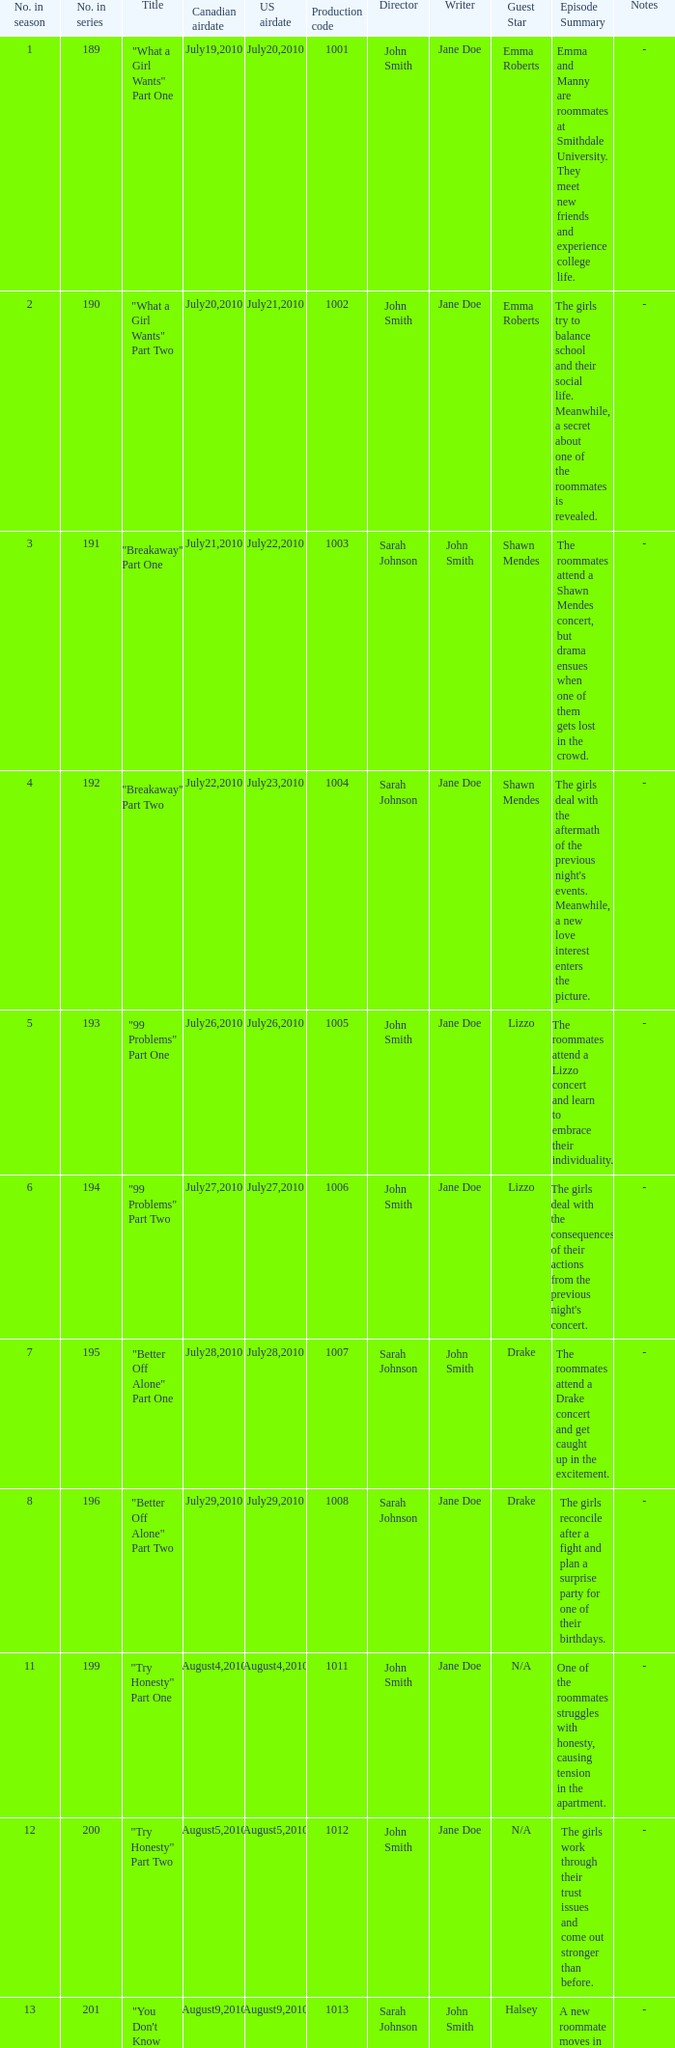Parse the full table. {'header': ['No. in season', 'No. in series', 'Title', 'Canadian airdate', 'US airdate', 'Production code', 'Director', 'Writer', 'Guest Star', 'Episode Summary', 'Notes'], 'rows': [['1', '189', '"What a Girl Wants" Part One', 'July19,2010', 'July20,2010', '1001', 'John Smith', 'Jane Doe', 'Emma Roberts', 'Emma and Manny are roommates at Smithdale University. They meet new friends and experience college life.', '-'], ['2', '190', '"What a Girl Wants" Part Two', 'July20,2010', 'July21,2010', '1002', 'John Smith', 'Jane Doe', 'Emma Roberts', 'The girls try to balance school and their social life. Meanwhile, a secret about one of the roommates is revealed.', '-'], ['3', '191', '"Breakaway" Part One', 'July21,2010', 'July22,2010', '1003', 'Sarah Johnson', 'John Smith', 'Shawn Mendes', 'The roommates attend a Shawn Mendes concert, but drama ensues when one of them gets lost in the crowd.', '-'], ['4', '192', '"Breakaway" Part Two', 'July22,2010', 'July23,2010', '1004', 'Sarah Johnson', 'Jane Doe', 'Shawn Mendes', "The girls deal with the aftermath of the previous night's events. Meanwhile, a new love interest enters the picture.", '-'], ['5', '193', '"99 Problems" Part One', 'July26,2010', 'July26,2010', '1005', 'John Smith', 'Jane Doe', 'Lizzo', 'The roommates attend a Lizzo concert and learn to embrace their individuality.', '-'], ['6', '194', '"99 Problems" Part Two', 'July27,2010', 'July27,2010', '1006', 'John Smith', 'Jane Doe', 'Lizzo', "The girls deal with the consequences of their actions from the previous night's concert.", '-'], ['7', '195', '"Better Off Alone" Part One', 'July28,2010', 'July28,2010', '1007', 'Sarah Johnson', 'John Smith', 'Drake', 'The roommates attend a Drake concert and get caught up in the excitement.', '-'], ['8', '196', '"Better Off Alone" Part Two', 'July29,2010', 'July29,2010', '1008', 'Sarah Johnson', 'Jane Doe', 'Drake', 'The girls reconcile after a fight and plan a surprise party for one of their birthdays.', '-'], ['11', '199', '"Try Honesty" Part One', 'August4,2010', 'August4,2010', '1011', 'John Smith', 'Jane Doe', 'N/A', 'One of the roommates struggles with honesty, causing tension in the apartment.', '-'], ['12', '200', '"Try Honesty" Part Two', 'August5,2010', 'August5,2010', '1012', 'John Smith', 'Jane Doe', 'N/A', 'The girls work through their trust issues and come out stronger than before.', '-'], ['13', '201', '"You Don\'t Know My Name" Part One', 'August9,2010', 'August9,2010', '1013', 'Sarah Johnson', 'John Smith', 'Halsey', 'A new roommate moves in and shakes things up.', '-'], ['14', '202', '"You Don\'t Know My Name" Part Two', 'August10,2010', 'August10,2010', '1014', 'Sarah Johnson', 'Jane Doe', 'Halsey', 'The girls learn more about their new roommate and bond over shared interests.', '-'], ['15', '203', '" My Body Is a Cage " Part One', 'August11,2010', 'August11,2010', '1015', 'John Smith', 'Jane Doe', 'Lady Gaga', 'One of the roommates opens up about a personal struggle.', '-'], ['16', '204', '" My Body Is a Cage " Part Two', 'August12,2010', 'August12,2010', '1016', 'John Smith', 'Jane Doe', 'Lady Gaga', 'The girls support their friend and come up with a plan to help her.', '-'], ['17', '205', '"Tears Dry on Their Own" Part One', 'August16,2010', 'August16,2010', '1017', 'Sarah Johnson', 'John Smith', 'N/A', 'The roommates deal with the aftermath of a breakup.', '-'], ['18', '206', '"Tears Dry on Their Own" Part Two', 'August17,2010', 'August17,2010', '1018', 'Sarah Johnson', 'Jane Doe', 'N/A', 'The girls help their friend move on and realize the importance of self-love.', '-'], ['19', '207', '"Still Fighting It" Part One', 'August18,2010', 'August18,2010', '1019', 'John Smith', 'Jane Doe', 'Ariana Grande', 'The roommates attend an Ariana Grande concert and deal with conflicting emotions.', '-'], ['20', '208', '"Still Fighting It" Part Two', 'August19,2010', 'August19,2010', '1020', 'John Smith', 'Jane Doe', 'Ariana Grande', 'The girls reflect on their personal journeys and how far they have come.', '-'], ['21', '209', '"Purple Pills" Part One', 'August23,2010', 'August23,2010', '1021', 'Sarah Johnson', 'John Smith', 'N/A', 'The roommates experiment with drugs and face the consequences of their actions.', '-'], ['22', '210', '"Purple Pills" Part Two', 'August24,2010', 'August24,2010', '1022', 'Sarah Johnson', 'Jane Doe', 'N/A', 'The girls deal with the fallout of their drug use and try to move forward.', '-'], ['23', '211', '"All Falls Down" Part One', 'August25,2010', 'August25,2010', '1023', 'John Smith', 'Jane Doe', 'Post Malone', 'The roommates attend a Post Malone concert and confront their insecurities.', '-'], ['24', '212', '"All Falls Down" Part Two', 'August26,2010', 'August26,2010', '1024', 'John Smith', 'Jane Doe', 'Post Malone', 'The girls support each other through personal struggles and make plans for the future.', '-'], ['25', '213', '"Don\'t Let Me Get Me" Part One', 'October8,2010', 'October8,2010', '1025', 'Sarah Johnson', 'John Smith', 'N/A', 'The roommates deal with a difficult roommate situation and try to find a solution.', '-'], ['26', '214', '"Don\'t Let Me Get Me" Part Two', 'October8,2010', 'October8,2010', '1026', 'Sarah Johnson', 'Jane Doe', 'N/A', 'The girls come up with a plan to improve their living situation and learn to communicate effectively.', '-'], ['27', '215', '"Love Lockdown" Part One', 'October15,2010', 'October15,2010', '1027', 'John Smith', 'Jane Doe', 'Justin Bieber', 'The roommates attend a Justin Bieber concert and reflect on their past relationships.', '-'], ['28', '216', '"Love Lockdown" Part Two', 'October22,2010', 'October22,2010', '1028', 'John Smith', 'Jane Doe', 'Justin Bieber', 'The girls confront their feelings about love and make decisions about their futures.', '-'], ['29', '217', '"Umbrella" Part One', 'October29,2010', 'October29,2010', '1029', 'Sarah Johnson', 'John Smith', 'Beyonce', 'The roommates attend a Beyonce concert and let their hair down.', '-'], ['30', '218', '"Umbrella" Part Two', 'November5,2010', 'November5,2010', '1030', 'Sarah Johnson', 'Jane Doe', 'Beyonce', 'The girls support each other through personal struggles and learn to lean on one another.', '-'], ['31', '219', '"Halo" Part One', 'November12,2010', 'November12,2010', '1031', 'John Smith', 'Jane Doe', 'N/A', 'One of the roommates faces a health scare and the others rally around her.', '-'], ['32', '220', '"Halo" Part Two', 'November19,2010', 'November19,2010', '1032', 'John Smith', 'Jane Doe', 'N/A', "The girls process their friend's diagnosis and show their love and support.", '-'], ['33', '221', '"When Love Takes Over" Part One', 'February11,2011', 'February11,2011', '1033', 'Sarah Johnson', 'John Smith', 'H.E.R.', 'The roommates attend an H.E.R. concert and bond over their shared love of music.', '-'], ['34', '222', '"When Love Takes Over" Part Two', 'February11,2011', 'February11,2011', '1034', 'Sarah Johnson', 'Jane Doe', 'H.E.R.', 'The girls navigate new relationships and unexpected challenges.', '-'], ['35', '223', '"The Way We Get By" Part One', 'February18,2011', 'February18,2011', '1035', 'John Smith', 'Jane Doe', 'Khalid', 'One of the roommates deals with a family emergency and the others offer their support.', '-'], ['36', '224', '"The Way We Get By" Part Two', 'February25,2011', 'February25,2011', '1036', 'John Smith', 'Jane Doe', 'Khalid', 'The girls reflect on their personal growth and how they have become a chosen family.', '-'], ['37', '225', '"Jesus, Etc." Part One', 'March4,2011', 'March4,2011', '1037', 'Sarah Johnson', 'John Smith', 'N/A', 'The roommates attend a spiritual retreat and confront their beliefs.', '-'], ['38', '226', '"Jesus, Etc." Part Two', 'March11,2011', 'March11,2011', '1038', 'Sarah Johnson', 'Jane Doe', 'N/A', 'The girls work through their differing worldviews and find common ground.', '-'], ['39', '227', '"Hide and Seek" Part One', 'March18,2011', 'March18,2011', '1039', 'John Smith', 'Jane Doe', 'N/A', 'The roommates deal with unexpected visitors and try to hide a secret.', '-'], ['40', '228', '"Hide and Seek" Part Two', 'March25,2011', 'March25,2011', '1040', 'John Smith', 'Jane Doe', 'N/A', 'The girls face the consequences of keeping a secret and work to repair their friendships.', '-'], ['41', '229', '"Chasing Pavements" Part One', 'April1,2011', 'April1,2011', '1041', 'Sarah Johnson', 'John Smith', 'Billie Eilish', 'The roommates attend a Billie Eilish concert and reflect on their personal goals and dreams.', '-'], ['42', '230', '"Chasing Pavements" Part Two', 'April8,2011', 'April8,2011', '1042', 'Sarah Johnson', 'Jane Doe', 'Billie Eilish', 'The girls make plans to achieve their goals and support each other along the way.', '-'], ['43', '231', '"Drop the World" Part One', 'April15,2011', 'April15,2011', '1043', 'John Smith', 'Jane Doe', 'Eminem', 'The roommates face unexpected challenges in their personal lives and struggle to cope.', '-']]} What was the us airdate of "love lockdown" part one? October15,2010. 